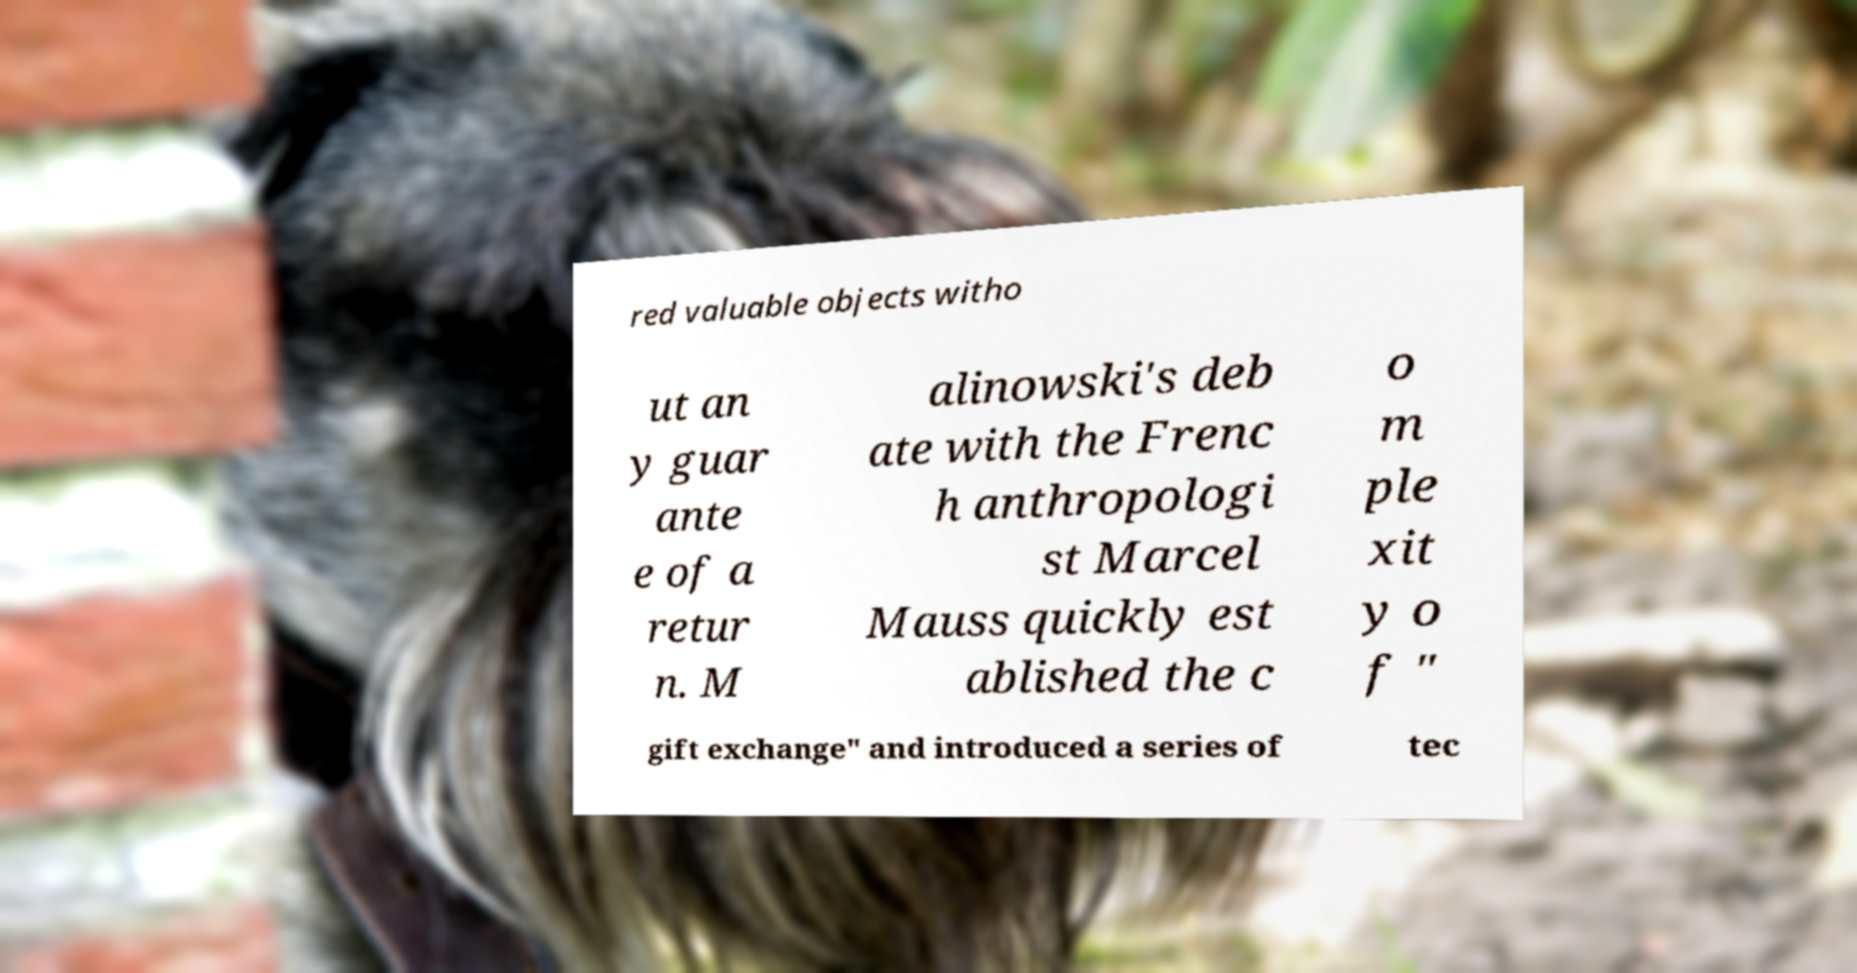I need the written content from this picture converted into text. Can you do that? red valuable objects witho ut an y guar ante e of a retur n. M alinowski's deb ate with the Frenc h anthropologi st Marcel Mauss quickly est ablished the c o m ple xit y o f " gift exchange" and introduced a series of tec 